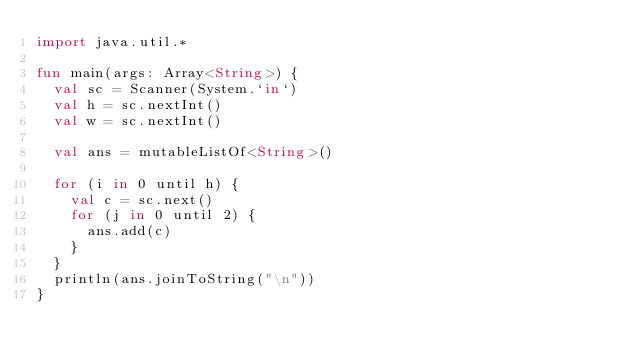Convert code to text. <code><loc_0><loc_0><loc_500><loc_500><_Kotlin_>import java.util.*

fun main(args: Array<String>) {
	val sc = Scanner(System.`in`)
	val h = sc.nextInt()
	val w = sc.nextInt()

	val ans = mutableListOf<String>()

	for (i in 0 until h) {
		val c = sc.next()
		for (j in 0 until 2) {
			ans.add(c)
		}
	}
	println(ans.joinToString("\n"))
}
</code> 